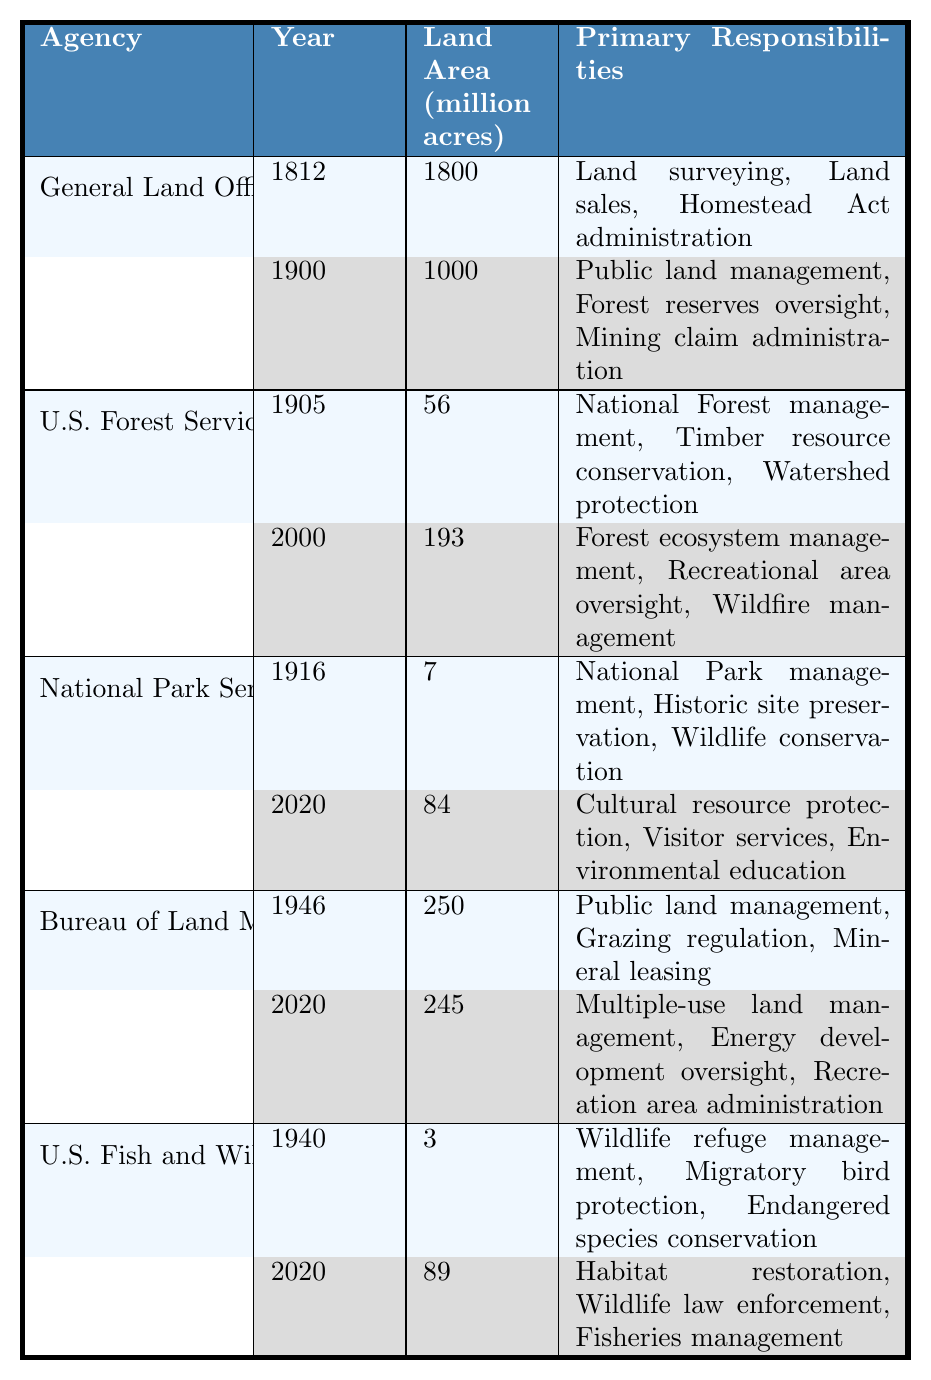What year was the General Land Office established? The table indicates that the General Land Office (GLO) was established in 1812.
Answer: 1812 What was the land area under the U.S. Forest Service's jurisdiction in 1905? According to the table, in 1905, the U.S. Forest Service had jurisdiction over 56 million acres of land.
Answer: 56 Which agency had the primary responsibility of "Wildlife refuge management" in 1940? The table states that the U.S. Fish and Wildlife Service had "Wildlife refuge management" as one of its primary responsibilities in 1940.
Answer: U.S. Fish and Wildlife Service How many million acres of land was managed by the Bureau of Land Management in 2020? The table shows that in 2020, the Bureau of Land Management managed 245 million acres of land.
Answer: 245 Which agency had the largest land area jurisdiction in 1812, and what was the area in million acres? The General Land Office (GLO) had the largest land area jurisdiction in 1812 with 1800 million acres.
Answer: General Land Office (GLO), 1800 What is the difference in land area managed by the National Park Service between 1916 and 2020? The National Park Service managed 7 million acres in 1916 and 84 million acres in 2020. The difference is calculated as 84 - 7 = 77 million acres.
Answer: 77 True or False: The U.S. Fish and Wildlife Service managed more land in 2020 than it did in 1940. In 1940, the U.S. Fish and Wildlife Service managed 3 million acres, while in 2020, it managed 89 million acres, confirming that it did manage more land in 2020.
Answer: True What is the total land area managed by the General Land Office (GLO) in 1900 and the U.S. Forest Service in 2000? The General Land Office managed 1000 million acres in 1900 and the U.S. Forest Service managed 193 million acres in 2000. Adding these gives 1000 + 193 = 1193 million acres.
Answer: 1193 What agency had the most significant change in primary responsibilities between 1916 and 2020? The National Park Service underwent significant changes in responsibilities, transitioning from "National Park management, Historic site preservation, Wildlife conservation" in 1916 to "Cultural resource protection, Visitor services, Environmental education" in 2020, indicating a broadened scope.
Answer: National Park Service What percentage of land area was managed by the Bureau of Land Management in 2020 compared to its area in 1946? The Bureau of Land Management managed 250 million acres in 1946 and 245 million acres in 2020. The percentage change is calculated as (245 - 250) / 250 * 100 = -2%.
Answer: -2% 